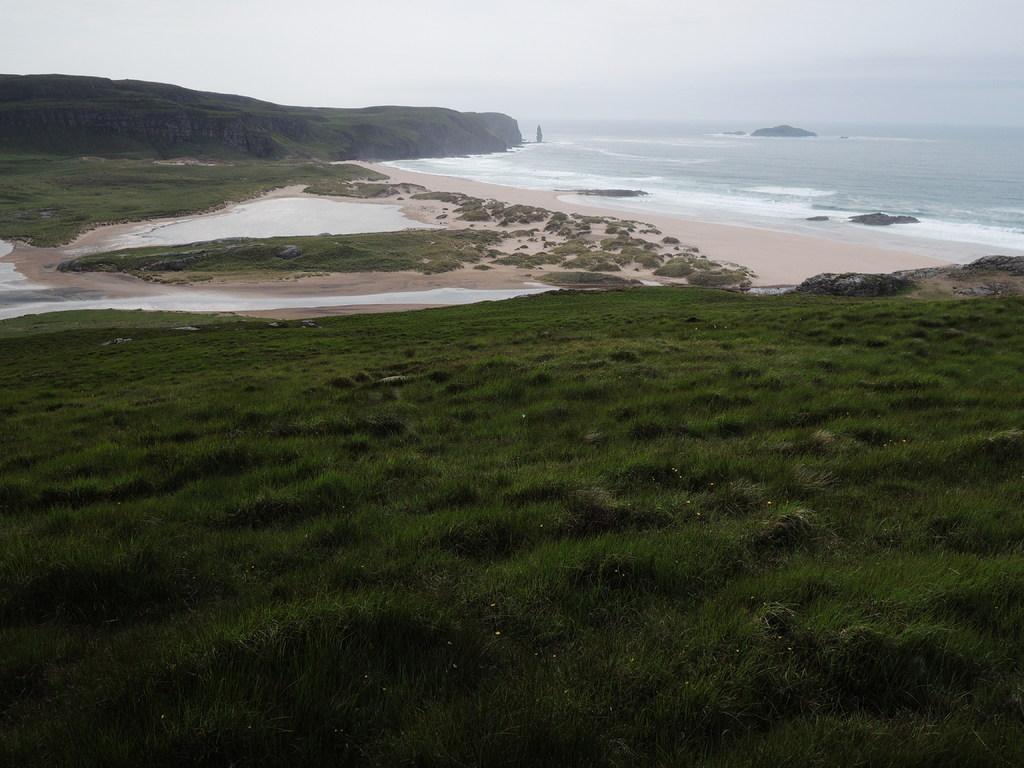Could you give a brief overview of what you see in this image? At the bottom of the image there is grass. In the background of the image there is sky and water. 